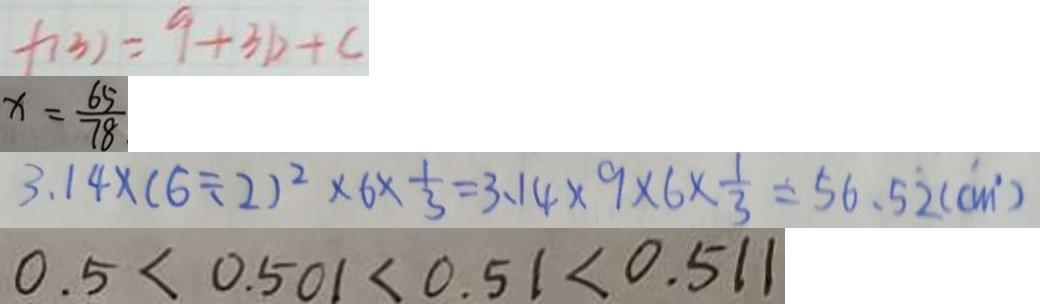<formula> <loc_0><loc_0><loc_500><loc_500>f ( 3 ) = 9 + 3 b + c 
 x = \frac { 6 5 } { 7 8 } 
 3 . 1 4 \times ( 6 \div 2 ) ^ { 2 } \times 6 \times \frac { 1 } { 3 } = 3 . 1 4 \times 9 \times 6 \times \frac { 1 } { 3 } = 5 6 . 5 \dot { 2 } ( c m ^ { 2 } ) 
 0 . 5 < 0 . 5 0 1 < 0 . 5 1 < 0 . 5 1 < 0 . 5 1 1</formula> 